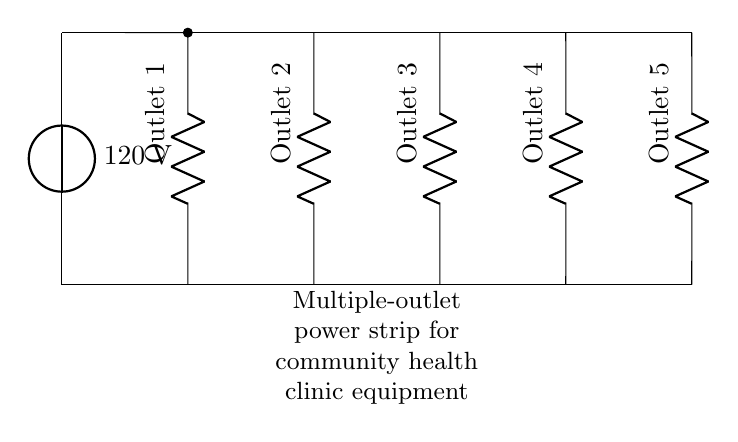What is the voltage of this circuit? The voltage is 120 volts, as indicated by the labeled voltage source in the diagram.
Answer: 120 volts How many outlets are shown in this circuit? There are five outlets shown in the diagram, each represented as a resistor symbol connected in parallel to the voltage source.
Answer: Five What type of circuit is represented here? This is a parallel circuit, as the outlets are connected across the same voltage source, allowing for individual operation.
Answer: Parallel What is the purpose of the multiple-outlet power strip? The purpose is to distribute electrical power from the voltage source to multiple outlets for clinic equipment use, allowing multiple devices to be plugged in simultaneously.
Answer: Power distribution If one outlet fails, what happens to the other outlets? The other outlets remain functional because they are in a parallel configuration, meaning each outlet operates independently.
Answer: Remain functional 